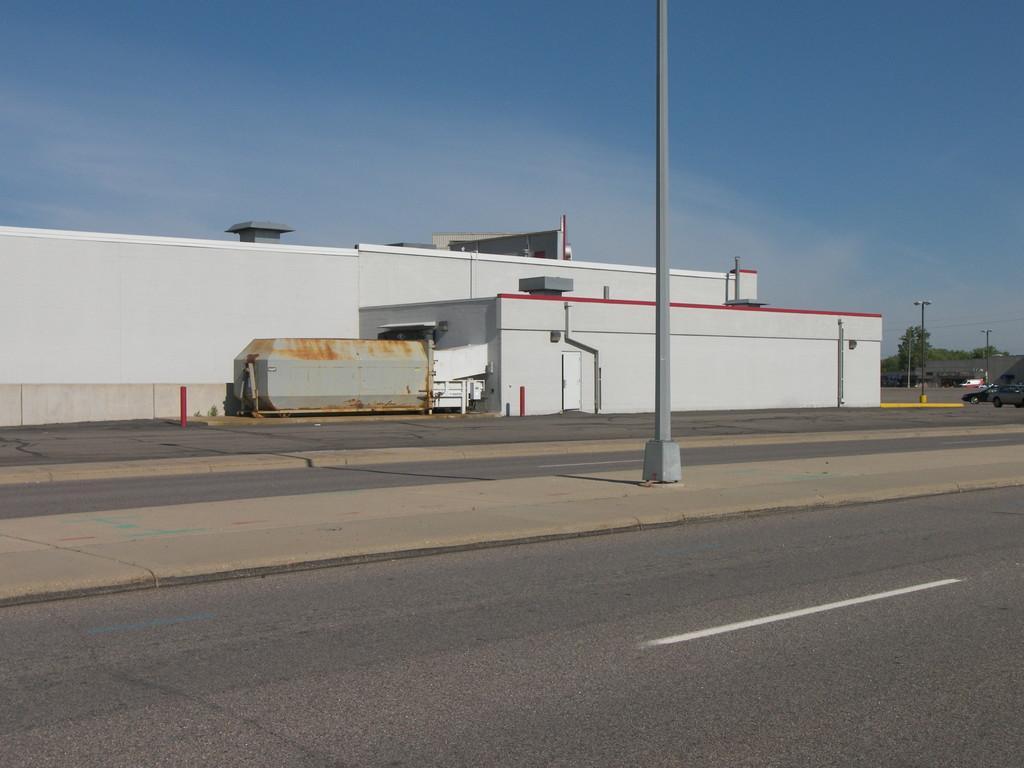Can you describe this image briefly? In this image we can see a road and a building and in the background there are some trees, two cars and poles in middle of the road. 